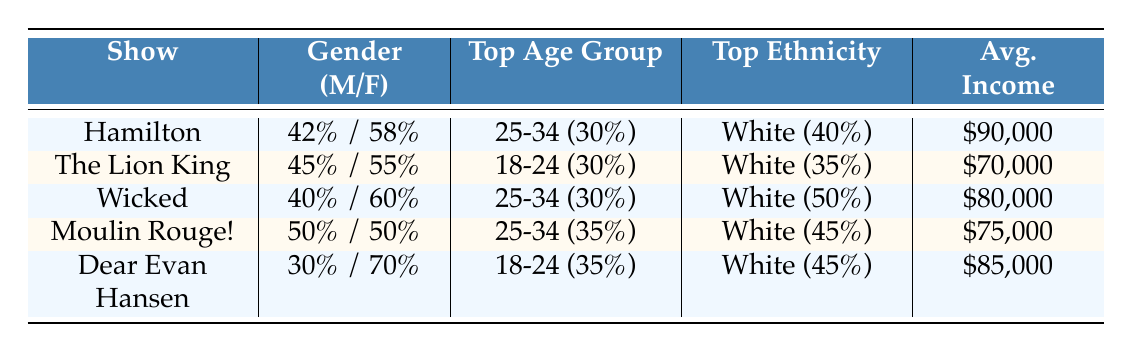What's the average income of the audiences for the shows? To find the average income, we sum the average incomes of all shows: $90,000 + $70,000 + $80,000 + $75,000 + $85,000 = $400,000. There are 5 shows, so the average income is $400,000 / 5 = $80,000.
Answer: $80,000 Which show has the highest percentage of female audience members? By reviewing the gender distribution in the table, we see that "Dear Evan Hansen" has the highest percentage of female attendees at 70%.
Answer: Dear Evan Hansen What is the top age group for "Moulin Rouge!"? Checking the age group column for "Moulin Rouge!", we see that its top age group is 25-34, with 35%.
Answer: 25-34 Is the majority of the audience for "The Lion King" under 18 years old? Looking at the age group data for "The Lion King," we find that only 20% of its audience is under 18, which is not a majority (over 50%). Therefore, the answer is no.
Answer: No Which show has the top ethnicity as "Black"? In the table, we review the ethnicity distribution for each show. "The Lion King" is the only show with "Black" making it to the top ethnicity at 25%.
Answer: The Lion King How do the male percentages compare between "Hamilton" and "Wicked"? "Hamilton" has 42% male audience members, while "Wicked" features 40% male. The comparison shows that "Hamilton" has a higher male percentage by 2%.
Answer: Hamilton has 2% more male audience What percentage of audience members for "Dear Evan Hansen" are aged 18-24? In the age group data for "Dear Evan Hansen", it indicates that 35% of its audience falls within the 18-24 age category.
Answer: 35% Does "Wicked" have a higher percentage of Hispanic audience members compared to "Hamilton"? "Wicked" reports 15% Hispanic audience while "Hamilton" has the same 15%. Since both are equal, the answer is no, "Wicked" does not have a higher percentage.
Answer: No Which show overall has the largest percentage of its audience within the age group 25-34? In the age group analysis, "Moulin Rouge!" has the largest percentage of 35% in the 25-34 category compared to the others.
Answer: Moulin Rouge! 